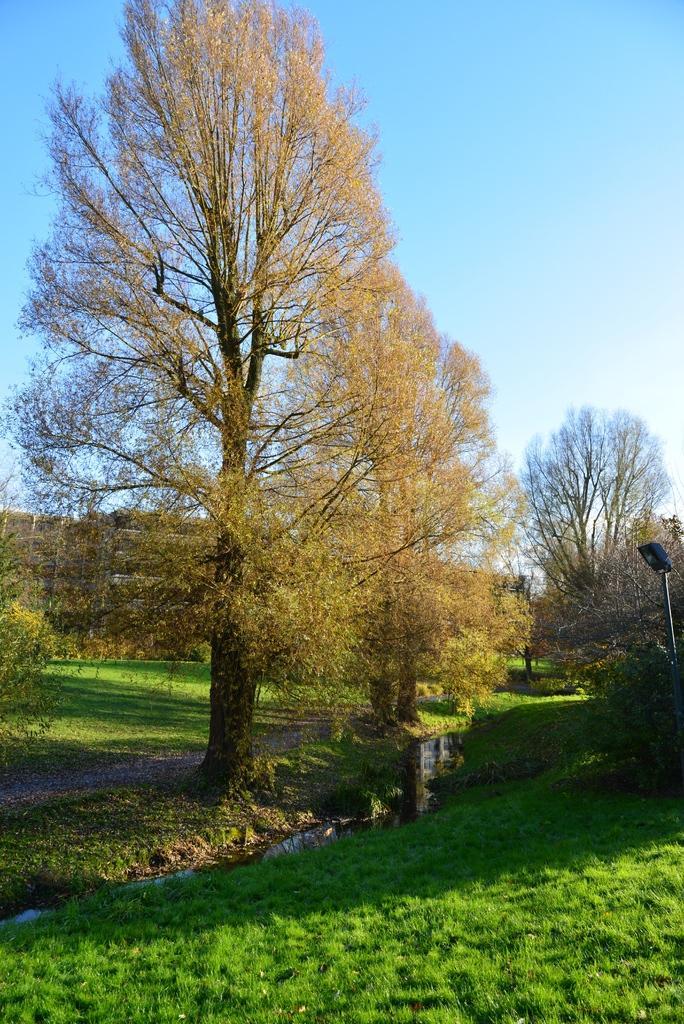In one or two sentences, can you explain what this image depicts? In the image we can see there is a ground covered with grass and behind there are lot of trees. There is a street light pole and there is a clear sky. 